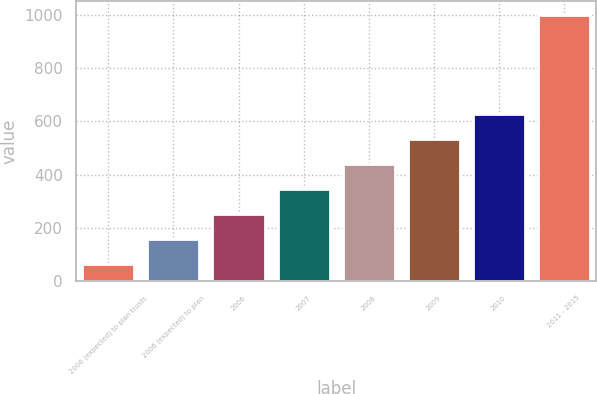Convert chart to OTSL. <chart><loc_0><loc_0><loc_500><loc_500><bar_chart><fcel>2006 (expected) to plan trusts<fcel>2006 (expected) to plan<fcel>2006<fcel>2007<fcel>2008<fcel>2009<fcel>2010<fcel>2011 - 2015<nl><fcel>65<fcel>158.5<fcel>252<fcel>345.5<fcel>439<fcel>532.5<fcel>626<fcel>1000<nl></chart> 